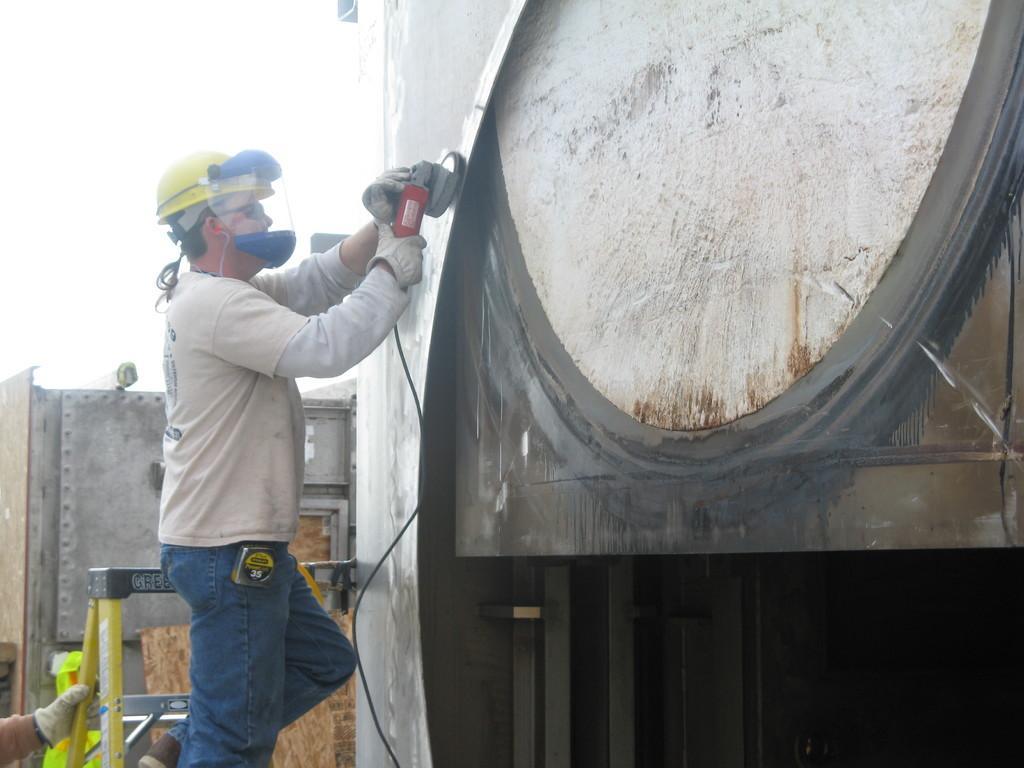Could you give a brief overview of what you see in this image? In this picture we can see a man standing and holding a angle grinder machine, he wore a helmet, at the bottom there is a ladder, we can see another person's hand at the left bottom, in the background there is a wall, we can see the sky at the top of the picture. 